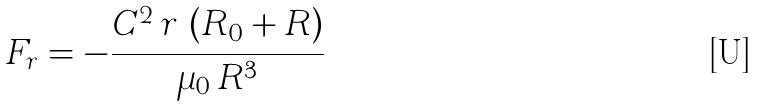Convert formula to latex. <formula><loc_0><loc_0><loc_500><loc_500>F _ { r } = - \frac { C ^ { 2 } \, r \, \left ( { R _ { 0 } + R } \right ) } { \mu _ { 0 } \, R ^ { 3 } }</formula> 